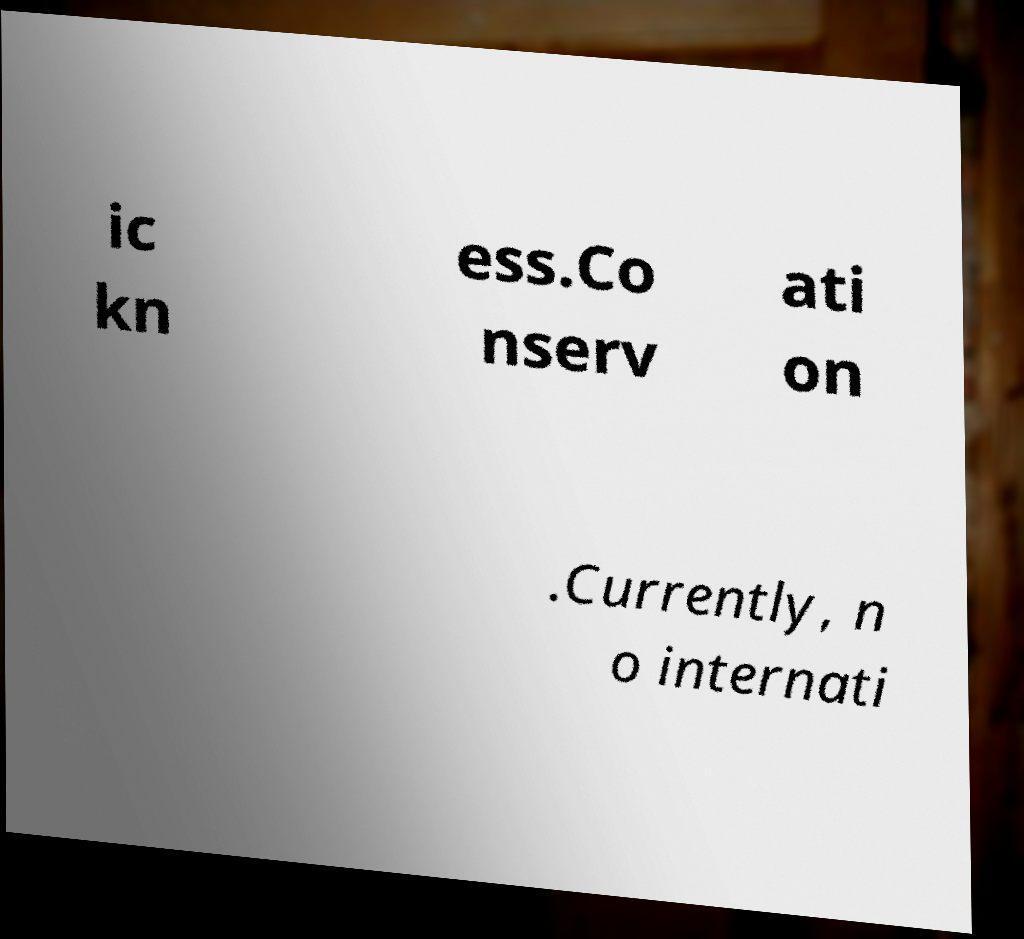I need the written content from this picture converted into text. Can you do that? ic kn ess.Co nserv ati on .Currently, n o internati 